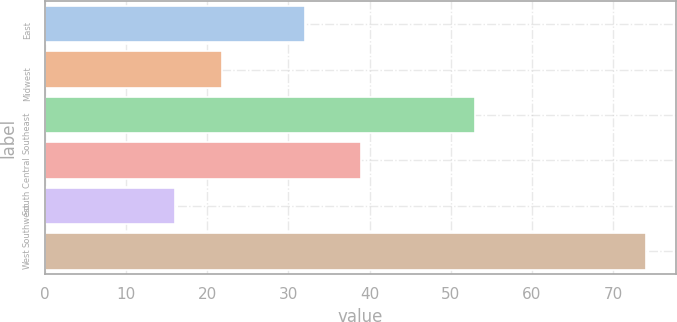<chart> <loc_0><loc_0><loc_500><loc_500><bar_chart><fcel>East<fcel>Midwest<fcel>Southeast<fcel>South Central<fcel>Southwest<fcel>West<nl><fcel>32<fcel>21.8<fcel>53<fcel>39<fcel>16<fcel>74<nl></chart> 